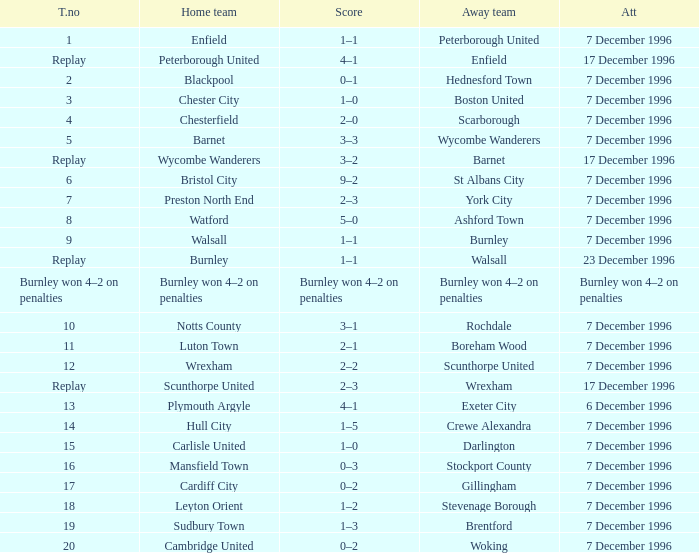Who were the away team in tie number 20? Woking. 